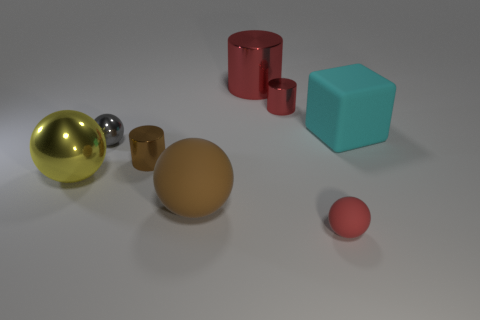Add 2 gray balls. How many objects exist? 10 Subtract all gray spheres. How many red cylinders are left? 2 Subtract all large brown matte balls. How many balls are left? 3 Subtract all gray balls. How many balls are left? 3 Subtract 2 spheres. How many spheres are left? 2 Subtract all cubes. How many objects are left? 7 Subtract all gray cylinders. Subtract all red blocks. How many cylinders are left? 3 Add 2 big brown rubber things. How many big brown rubber things are left? 3 Add 7 big shiny balls. How many big shiny balls exist? 8 Subtract 1 yellow spheres. How many objects are left? 7 